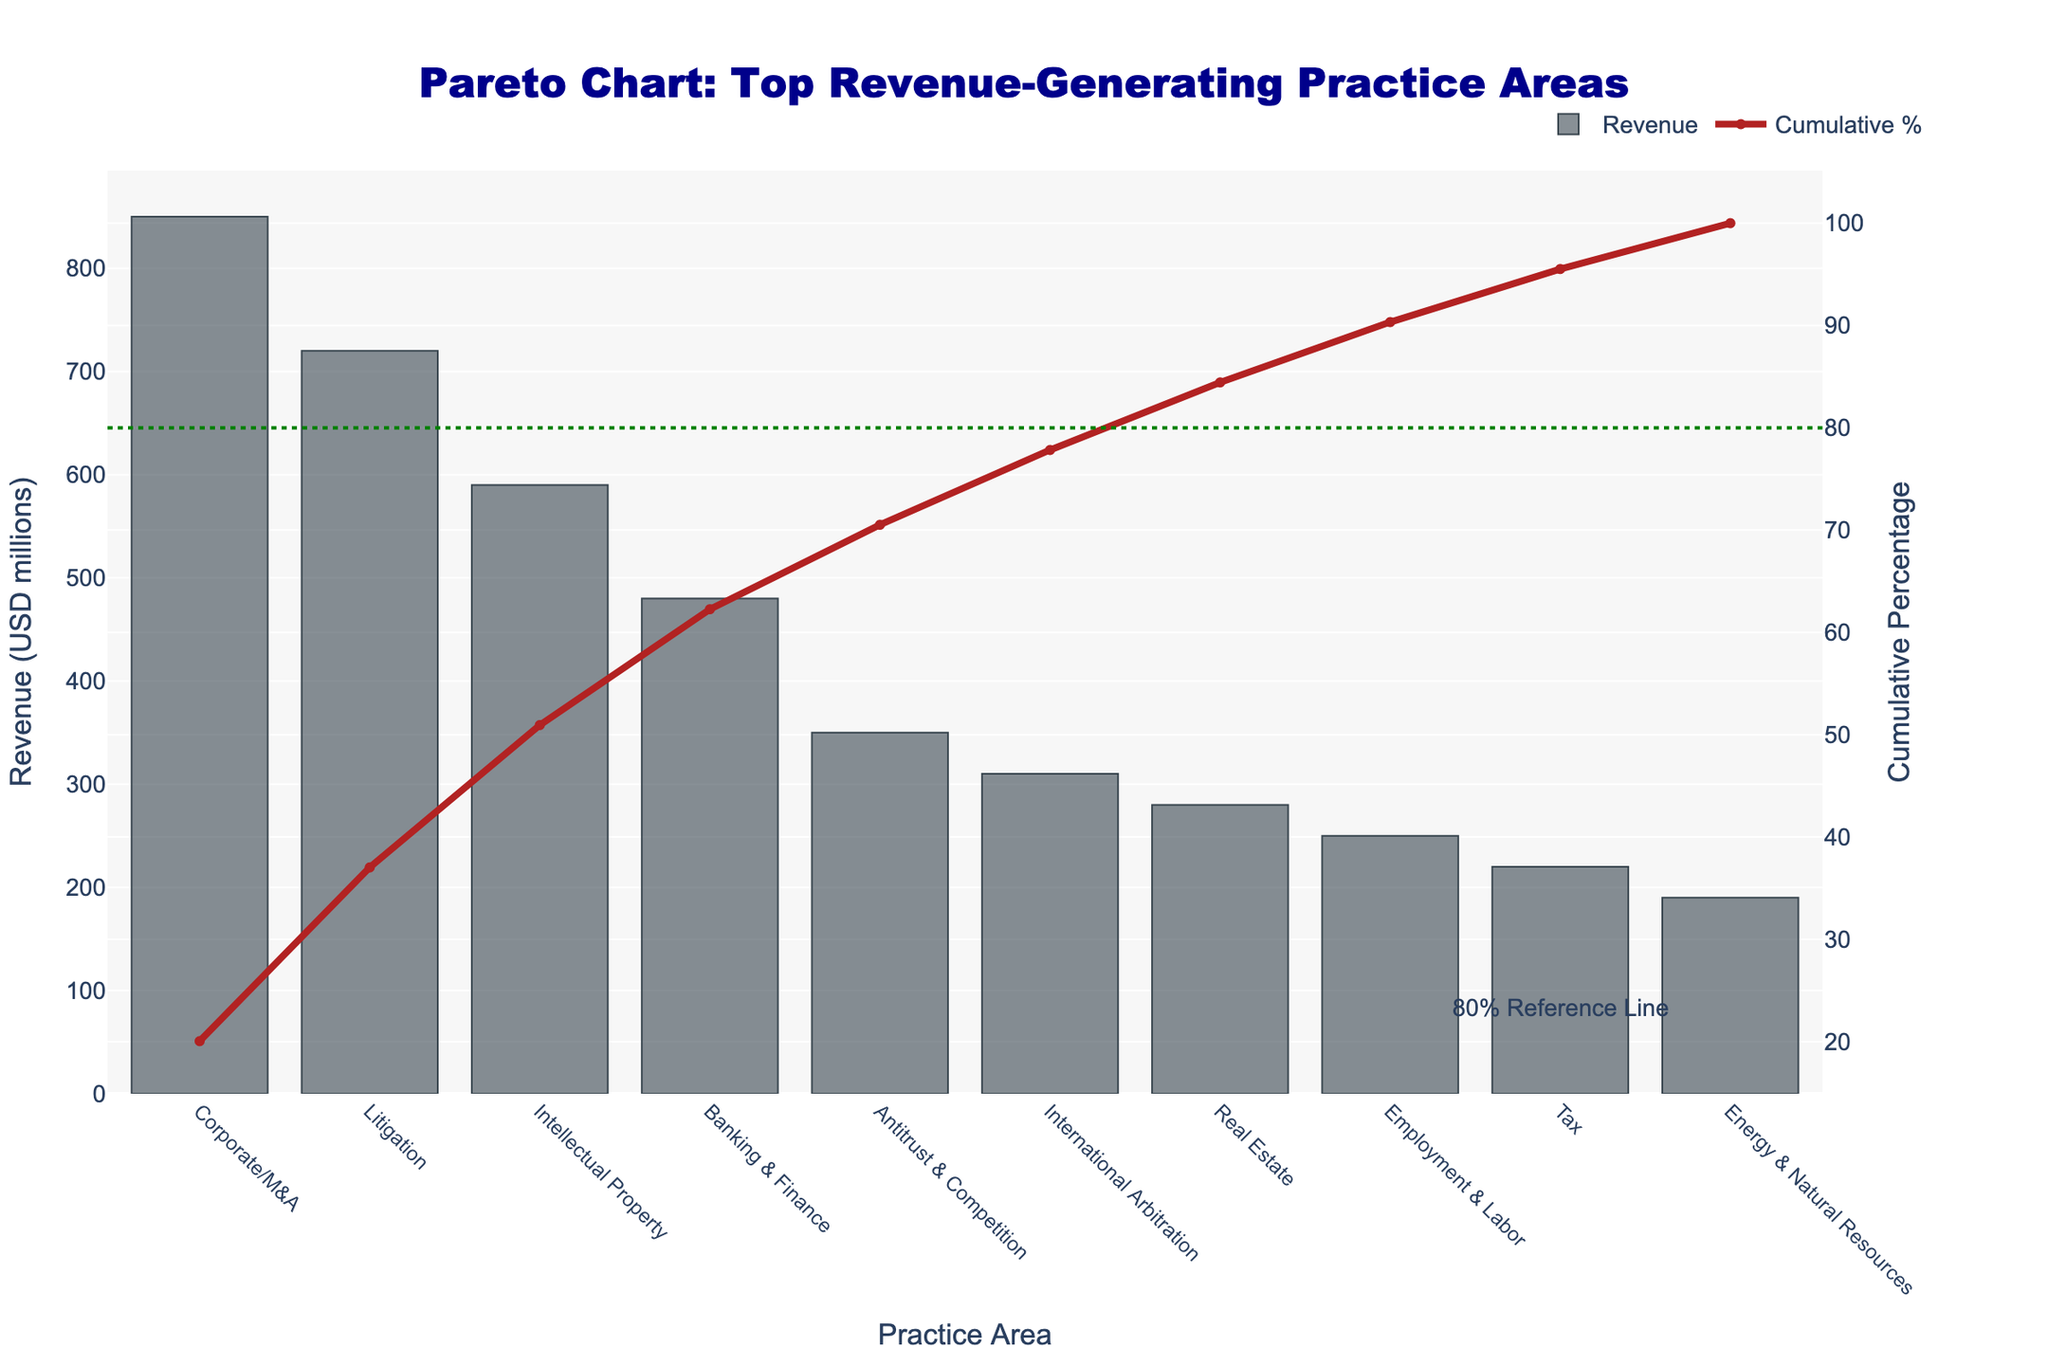What's the title of the chart? The title is prominently positioned at the top of the chart in large blue font, which reads: "Pareto Chart: Top Revenue-Generating Practice Areas".
Answer: Pareto Chart: Top Revenue-Generating Practice Areas Which practice area generates the highest revenue? The practice area with the tallest bar on the chart indicates it has the highest revenue. In this chart, the "Corporate/M&A" practice area has the tallest bar.
Answer: Corporate/M&A What is the revenue generated by the Litigation practice area? The bar corresponding to "Litigation" practice area reaches up to the value indicated on the left y-axis. This practice area generates 720 million USD.
Answer: 720 million USD How many practice areas contribute to 80% of the cumulative revenue? We look at the red cumulative percentage line and see where it intersects with the green 80% reference line. The intersection falls after the 5th practice area from left to right.
Answer: 5 practice areas What is the cumulative percentage of revenue for the Corporate/M&A and Litigation practice areas combined? The cumulative percentage for Corporate/M&A is 34.51% and for Litigation is 63.75%, as per the cumulative percentage line traced from both bars. By adding them: 34.51 + 29.24 = 63.75.
Answer: 63.75% Which practice area is directly responsible for increasing the cumulative percentage of revenue from 80% to above 100%? Follow the red cumulative percentage line and see which practice area's stacked bar increases the cumulative percentage from the green 80% line up to past 100%. This corresponds to "Employment & Labor".
Answer: Employment & Labor How does the cumulative percentage for the top three revenue-generating practice areas compare to the 80% reference line? We can observe from the cumulative percentage line and compare values. The cumulative percentage after Corporate/M&A, Litigation, and Intellectual Property is 72.84%, which is less than 80%.
Answer: Less than 80% What is the difference in revenue between the highest and the lowest revenue-generating practice areas? Subtract the revenue of the lowest revenue-generating practice area ("Energy & Natural Resources", 190 million USD) from the highest ("Corporate/M&A", 850 million USD). The difference is 850 - 190 = 660 million USD.
Answer: 660 million USD Is the revenue distribution heavily skewed towards a few practice areas? By observing the steeper slope of the cumulative percentage line in the initial part of the chart and the considerable heights of the first few bars compared to the latter, it indicates a skewed distribution.
Answer: Yes, it is heavily skewed 